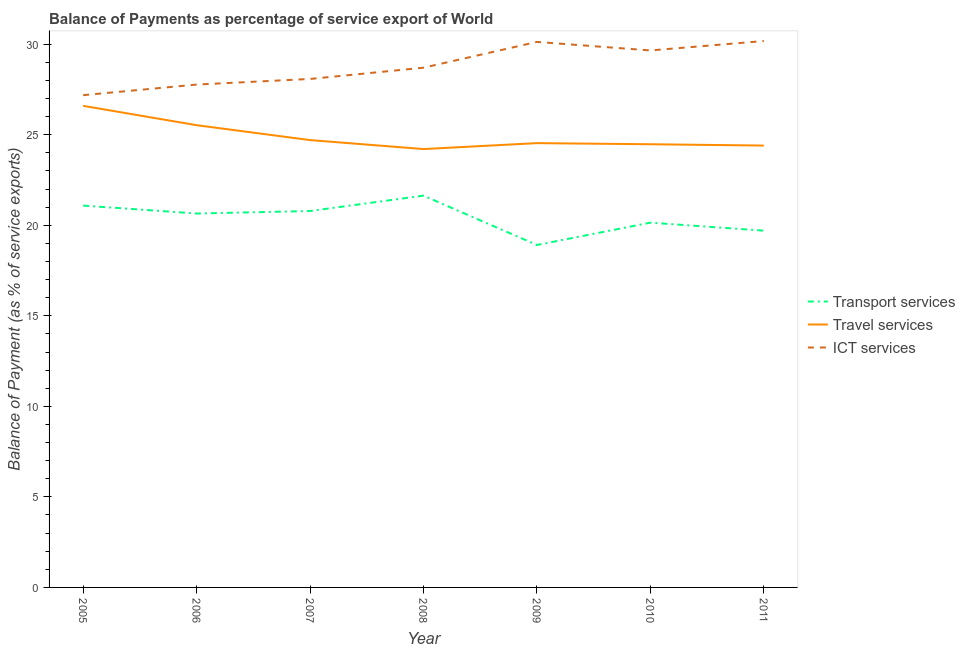How many different coloured lines are there?
Offer a terse response. 3. Does the line corresponding to balance of payment of travel services intersect with the line corresponding to balance of payment of transport services?
Offer a very short reply. No. Is the number of lines equal to the number of legend labels?
Make the answer very short. Yes. What is the balance of payment of ict services in 2008?
Keep it short and to the point. 28.7. Across all years, what is the maximum balance of payment of travel services?
Offer a terse response. 26.59. Across all years, what is the minimum balance of payment of travel services?
Your answer should be very brief. 24.21. In which year was the balance of payment of travel services minimum?
Ensure brevity in your answer.  2008. What is the total balance of payment of ict services in the graph?
Offer a terse response. 201.69. What is the difference between the balance of payment of travel services in 2008 and that in 2011?
Keep it short and to the point. -0.19. What is the difference between the balance of payment of transport services in 2008 and the balance of payment of travel services in 2007?
Offer a terse response. -3.07. What is the average balance of payment of travel services per year?
Provide a short and direct response. 24.92. In the year 2008, what is the difference between the balance of payment of transport services and balance of payment of travel services?
Make the answer very short. -2.57. In how many years, is the balance of payment of travel services greater than 18 %?
Your response must be concise. 7. What is the ratio of the balance of payment of ict services in 2010 to that in 2011?
Make the answer very short. 0.98. Is the balance of payment of travel services in 2005 less than that in 2006?
Provide a short and direct response. No. Is the difference between the balance of payment of transport services in 2005 and 2008 greater than the difference between the balance of payment of ict services in 2005 and 2008?
Ensure brevity in your answer.  Yes. What is the difference between the highest and the second highest balance of payment of ict services?
Your answer should be very brief. 0.05. What is the difference between the highest and the lowest balance of payment of ict services?
Your response must be concise. 2.99. In how many years, is the balance of payment of travel services greater than the average balance of payment of travel services taken over all years?
Keep it short and to the point. 2. Is it the case that in every year, the sum of the balance of payment of transport services and balance of payment of travel services is greater than the balance of payment of ict services?
Your answer should be compact. Yes. Does the balance of payment of transport services monotonically increase over the years?
Provide a succinct answer. No. What is the difference between two consecutive major ticks on the Y-axis?
Ensure brevity in your answer.  5. Does the graph contain any zero values?
Offer a terse response. No. Does the graph contain grids?
Ensure brevity in your answer.  No. Where does the legend appear in the graph?
Make the answer very short. Center right. What is the title of the graph?
Your answer should be very brief. Balance of Payments as percentage of service export of World. What is the label or title of the Y-axis?
Make the answer very short. Balance of Payment (as % of service exports). What is the Balance of Payment (as % of service exports) of Transport services in 2005?
Give a very brief answer. 21.09. What is the Balance of Payment (as % of service exports) of Travel services in 2005?
Your answer should be very brief. 26.59. What is the Balance of Payment (as % of service exports) in ICT services in 2005?
Offer a very short reply. 27.19. What is the Balance of Payment (as % of service exports) of Transport services in 2006?
Your answer should be very brief. 20.65. What is the Balance of Payment (as % of service exports) in Travel services in 2006?
Your response must be concise. 25.53. What is the Balance of Payment (as % of service exports) in ICT services in 2006?
Offer a terse response. 27.77. What is the Balance of Payment (as % of service exports) in Transport services in 2007?
Ensure brevity in your answer.  20.79. What is the Balance of Payment (as % of service exports) in Travel services in 2007?
Give a very brief answer. 24.7. What is the Balance of Payment (as % of service exports) in ICT services in 2007?
Your answer should be very brief. 28.08. What is the Balance of Payment (as % of service exports) in Transport services in 2008?
Provide a short and direct response. 21.64. What is the Balance of Payment (as % of service exports) in Travel services in 2008?
Your answer should be very brief. 24.21. What is the Balance of Payment (as % of service exports) in ICT services in 2008?
Give a very brief answer. 28.7. What is the Balance of Payment (as % of service exports) in Transport services in 2009?
Offer a terse response. 18.91. What is the Balance of Payment (as % of service exports) of Travel services in 2009?
Keep it short and to the point. 24.54. What is the Balance of Payment (as % of service exports) of ICT services in 2009?
Your answer should be compact. 30.13. What is the Balance of Payment (as % of service exports) of Transport services in 2010?
Your response must be concise. 20.14. What is the Balance of Payment (as % of service exports) of Travel services in 2010?
Offer a very short reply. 24.47. What is the Balance of Payment (as % of service exports) of ICT services in 2010?
Keep it short and to the point. 29.65. What is the Balance of Payment (as % of service exports) of Transport services in 2011?
Give a very brief answer. 19.7. What is the Balance of Payment (as % of service exports) in Travel services in 2011?
Keep it short and to the point. 24.4. What is the Balance of Payment (as % of service exports) in ICT services in 2011?
Keep it short and to the point. 30.17. Across all years, what is the maximum Balance of Payment (as % of service exports) of Transport services?
Your answer should be very brief. 21.64. Across all years, what is the maximum Balance of Payment (as % of service exports) of Travel services?
Give a very brief answer. 26.59. Across all years, what is the maximum Balance of Payment (as % of service exports) in ICT services?
Give a very brief answer. 30.17. Across all years, what is the minimum Balance of Payment (as % of service exports) of Transport services?
Your answer should be compact. 18.91. Across all years, what is the minimum Balance of Payment (as % of service exports) of Travel services?
Give a very brief answer. 24.21. Across all years, what is the minimum Balance of Payment (as % of service exports) in ICT services?
Your answer should be very brief. 27.19. What is the total Balance of Payment (as % of service exports) in Transport services in the graph?
Provide a short and direct response. 142.92. What is the total Balance of Payment (as % of service exports) in Travel services in the graph?
Offer a very short reply. 174.45. What is the total Balance of Payment (as % of service exports) of ICT services in the graph?
Offer a very short reply. 201.69. What is the difference between the Balance of Payment (as % of service exports) in Transport services in 2005 and that in 2006?
Offer a terse response. 0.44. What is the difference between the Balance of Payment (as % of service exports) in Travel services in 2005 and that in 2006?
Keep it short and to the point. 1.07. What is the difference between the Balance of Payment (as % of service exports) of ICT services in 2005 and that in 2006?
Your answer should be compact. -0.59. What is the difference between the Balance of Payment (as % of service exports) of Transport services in 2005 and that in 2007?
Give a very brief answer. 0.3. What is the difference between the Balance of Payment (as % of service exports) in Travel services in 2005 and that in 2007?
Your response must be concise. 1.89. What is the difference between the Balance of Payment (as % of service exports) of ICT services in 2005 and that in 2007?
Give a very brief answer. -0.9. What is the difference between the Balance of Payment (as % of service exports) in Transport services in 2005 and that in 2008?
Your response must be concise. -0.55. What is the difference between the Balance of Payment (as % of service exports) of Travel services in 2005 and that in 2008?
Ensure brevity in your answer.  2.39. What is the difference between the Balance of Payment (as % of service exports) in ICT services in 2005 and that in 2008?
Ensure brevity in your answer.  -1.52. What is the difference between the Balance of Payment (as % of service exports) of Transport services in 2005 and that in 2009?
Provide a succinct answer. 2.18. What is the difference between the Balance of Payment (as % of service exports) in Travel services in 2005 and that in 2009?
Keep it short and to the point. 2.06. What is the difference between the Balance of Payment (as % of service exports) of ICT services in 2005 and that in 2009?
Your response must be concise. -2.94. What is the difference between the Balance of Payment (as % of service exports) in Transport services in 2005 and that in 2010?
Offer a very short reply. 0.94. What is the difference between the Balance of Payment (as % of service exports) of Travel services in 2005 and that in 2010?
Give a very brief answer. 2.12. What is the difference between the Balance of Payment (as % of service exports) in ICT services in 2005 and that in 2010?
Your answer should be very brief. -2.47. What is the difference between the Balance of Payment (as % of service exports) of Transport services in 2005 and that in 2011?
Your answer should be compact. 1.39. What is the difference between the Balance of Payment (as % of service exports) of Travel services in 2005 and that in 2011?
Provide a short and direct response. 2.19. What is the difference between the Balance of Payment (as % of service exports) in ICT services in 2005 and that in 2011?
Make the answer very short. -2.99. What is the difference between the Balance of Payment (as % of service exports) of Transport services in 2006 and that in 2007?
Ensure brevity in your answer.  -0.14. What is the difference between the Balance of Payment (as % of service exports) of Travel services in 2006 and that in 2007?
Make the answer very short. 0.82. What is the difference between the Balance of Payment (as % of service exports) in ICT services in 2006 and that in 2007?
Make the answer very short. -0.31. What is the difference between the Balance of Payment (as % of service exports) in Transport services in 2006 and that in 2008?
Your answer should be very brief. -0.99. What is the difference between the Balance of Payment (as % of service exports) in Travel services in 2006 and that in 2008?
Provide a succinct answer. 1.32. What is the difference between the Balance of Payment (as % of service exports) in ICT services in 2006 and that in 2008?
Keep it short and to the point. -0.93. What is the difference between the Balance of Payment (as % of service exports) of Transport services in 2006 and that in 2009?
Make the answer very short. 1.74. What is the difference between the Balance of Payment (as % of service exports) in Travel services in 2006 and that in 2009?
Make the answer very short. 0.99. What is the difference between the Balance of Payment (as % of service exports) in ICT services in 2006 and that in 2009?
Your answer should be very brief. -2.36. What is the difference between the Balance of Payment (as % of service exports) in Transport services in 2006 and that in 2010?
Offer a very short reply. 0.5. What is the difference between the Balance of Payment (as % of service exports) of Travel services in 2006 and that in 2010?
Offer a terse response. 1.05. What is the difference between the Balance of Payment (as % of service exports) of ICT services in 2006 and that in 2010?
Provide a succinct answer. -1.88. What is the difference between the Balance of Payment (as % of service exports) of Transport services in 2006 and that in 2011?
Give a very brief answer. 0.95. What is the difference between the Balance of Payment (as % of service exports) of Travel services in 2006 and that in 2011?
Make the answer very short. 1.12. What is the difference between the Balance of Payment (as % of service exports) of ICT services in 2006 and that in 2011?
Offer a terse response. -2.4. What is the difference between the Balance of Payment (as % of service exports) in Transport services in 2007 and that in 2008?
Ensure brevity in your answer.  -0.85. What is the difference between the Balance of Payment (as % of service exports) in Travel services in 2007 and that in 2008?
Ensure brevity in your answer.  0.5. What is the difference between the Balance of Payment (as % of service exports) in ICT services in 2007 and that in 2008?
Offer a very short reply. -0.62. What is the difference between the Balance of Payment (as % of service exports) of Transport services in 2007 and that in 2009?
Offer a very short reply. 1.88. What is the difference between the Balance of Payment (as % of service exports) of Travel services in 2007 and that in 2009?
Offer a terse response. 0.17. What is the difference between the Balance of Payment (as % of service exports) in ICT services in 2007 and that in 2009?
Give a very brief answer. -2.05. What is the difference between the Balance of Payment (as % of service exports) in Transport services in 2007 and that in 2010?
Your response must be concise. 0.64. What is the difference between the Balance of Payment (as % of service exports) in Travel services in 2007 and that in 2010?
Give a very brief answer. 0.23. What is the difference between the Balance of Payment (as % of service exports) of ICT services in 2007 and that in 2010?
Make the answer very short. -1.57. What is the difference between the Balance of Payment (as % of service exports) of Transport services in 2007 and that in 2011?
Ensure brevity in your answer.  1.08. What is the difference between the Balance of Payment (as % of service exports) in Travel services in 2007 and that in 2011?
Offer a terse response. 0.3. What is the difference between the Balance of Payment (as % of service exports) of ICT services in 2007 and that in 2011?
Make the answer very short. -2.09. What is the difference between the Balance of Payment (as % of service exports) in Transport services in 2008 and that in 2009?
Offer a very short reply. 2.73. What is the difference between the Balance of Payment (as % of service exports) of Travel services in 2008 and that in 2009?
Make the answer very short. -0.33. What is the difference between the Balance of Payment (as % of service exports) of ICT services in 2008 and that in 2009?
Provide a succinct answer. -1.42. What is the difference between the Balance of Payment (as % of service exports) of Transport services in 2008 and that in 2010?
Ensure brevity in your answer.  1.49. What is the difference between the Balance of Payment (as % of service exports) in Travel services in 2008 and that in 2010?
Your answer should be compact. -0.27. What is the difference between the Balance of Payment (as % of service exports) in ICT services in 2008 and that in 2010?
Offer a very short reply. -0.95. What is the difference between the Balance of Payment (as % of service exports) in Transport services in 2008 and that in 2011?
Keep it short and to the point. 1.93. What is the difference between the Balance of Payment (as % of service exports) of Travel services in 2008 and that in 2011?
Your answer should be very brief. -0.19. What is the difference between the Balance of Payment (as % of service exports) in ICT services in 2008 and that in 2011?
Your answer should be compact. -1.47. What is the difference between the Balance of Payment (as % of service exports) in Transport services in 2009 and that in 2010?
Ensure brevity in your answer.  -1.23. What is the difference between the Balance of Payment (as % of service exports) of Travel services in 2009 and that in 2010?
Offer a very short reply. 0.06. What is the difference between the Balance of Payment (as % of service exports) of ICT services in 2009 and that in 2010?
Make the answer very short. 0.47. What is the difference between the Balance of Payment (as % of service exports) of Transport services in 2009 and that in 2011?
Your response must be concise. -0.79. What is the difference between the Balance of Payment (as % of service exports) in Travel services in 2009 and that in 2011?
Offer a very short reply. 0.13. What is the difference between the Balance of Payment (as % of service exports) in ICT services in 2009 and that in 2011?
Provide a succinct answer. -0.05. What is the difference between the Balance of Payment (as % of service exports) in Transport services in 2010 and that in 2011?
Ensure brevity in your answer.  0.44. What is the difference between the Balance of Payment (as % of service exports) of Travel services in 2010 and that in 2011?
Provide a short and direct response. 0.07. What is the difference between the Balance of Payment (as % of service exports) of ICT services in 2010 and that in 2011?
Make the answer very short. -0.52. What is the difference between the Balance of Payment (as % of service exports) of Transport services in 2005 and the Balance of Payment (as % of service exports) of Travel services in 2006?
Provide a short and direct response. -4.44. What is the difference between the Balance of Payment (as % of service exports) of Transport services in 2005 and the Balance of Payment (as % of service exports) of ICT services in 2006?
Keep it short and to the point. -6.68. What is the difference between the Balance of Payment (as % of service exports) in Travel services in 2005 and the Balance of Payment (as % of service exports) in ICT services in 2006?
Your answer should be very brief. -1.18. What is the difference between the Balance of Payment (as % of service exports) in Transport services in 2005 and the Balance of Payment (as % of service exports) in Travel services in 2007?
Make the answer very short. -3.62. What is the difference between the Balance of Payment (as % of service exports) in Transport services in 2005 and the Balance of Payment (as % of service exports) in ICT services in 2007?
Your answer should be compact. -6.99. What is the difference between the Balance of Payment (as % of service exports) in Travel services in 2005 and the Balance of Payment (as % of service exports) in ICT services in 2007?
Your answer should be compact. -1.49. What is the difference between the Balance of Payment (as % of service exports) in Transport services in 2005 and the Balance of Payment (as % of service exports) in Travel services in 2008?
Your response must be concise. -3.12. What is the difference between the Balance of Payment (as % of service exports) in Transport services in 2005 and the Balance of Payment (as % of service exports) in ICT services in 2008?
Provide a short and direct response. -7.61. What is the difference between the Balance of Payment (as % of service exports) of Travel services in 2005 and the Balance of Payment (as % of service exports) of ICT services in 2008?
Provide a succinct answer. -2.11. What is the difference between the Balance of Payment (as % of service exports) of Transport services in 2005 and the Balance of Payment (as % of service exports) of Travel services in 2009?
Make the answer very short. -3.45. What is the difference between the Balance of Payment (as % of service exports) in Transport services in 2005 and the Balance of Payment (as % of service exports) in ICT services in 2009?
Offer a very short reply. -9.04. What is the difference between the Balance of Payment (as % of service exports) of Travel services in 2005 and the Balance of Payment (as % of service exports) of ICT services in 2009?
Your answer should be very brief. -3.53. What is the difference between the Balance of Payment (as % of service exports) in Transport services in 2005 and the Balance of Payment (as % of service exports) in Travel services in 2010?
Keep it short and to the point. -3.39. What is the difference between the Balance of Payment (as % of service exports) in Transport services in 2005 and the Balance of Payment (as % of service exports) in ICT services in 2010?
Your answer should be compact. -8.57. What is the difference between the Balance of Payment (as % of service exports) of Travel services in 2005 and the Balance of Payment (as % of service exports) of ICT services in 2010?
Provide a succinct answer. -3.06. What is the difference between the Balance of Payment (as % of service exports) of Transport services in 2005 and the Balance of Payment (as % of service exports) of Travel services in 2011?
Give a very brief answer. -3.31. What is the difference between the Balance of Payment (as % of service exports) in Transport services in 2005 and the Balance of Payment (as % of service exports) in ICT services in 2011?
Give a very brief answer. -9.09. What is the difference between the Balance of Payment (as % of service exports) of Travel services in 2005 and the Balance of Payment (as % of service exports) of ICT services in 2011?
Offer a very short reply. -3.58. What is the difference between the Balance of Payment (as % of service exports) of Transport services in 2006 and the Balance of Payment (as % of service exports) of Travel services in 2007?
Provide a short and direct response. -4.06. What is the difference between the Balance of Payment (as % of service exports) of Transport services in 2006 and the Balance of Payment (as % of service exports) of ICT services in 2007?
Your answer should be compact. -7.43. What is the difference between the Balance of Payment (as % of service exports) in Travel services in 2006 and the Balance of Payment (as % of service exports) in ICT services in 2007?
Give a very brief answer. -2.55. What is the difference between the Balance of Payment (as % of service exports) of Transport services in 2006 and the Balance of Payment (as % of service exports) of Travel services in 2008?
Your response must be concise. -3.56. What is the difference between the Balance of Payment (as % of service exports) of Transport services in 2006 and the Balance of Payment (as % of service exports) of ICT services in 2008?
Your response must be concise. -8.05. What is the difference between the Balance of Payment (as % of service exports) of Travel services in 2006 and the Balance of Payment (as % of service exports) of ICT services in 2008?
Provide a short and direct response. -3.18. What is the difference between the Balance of Payment (as % of service exports) in Transport services in 2006 and the Balance of Payment (as % of service exports) in Travel services in 2009?
Ensure brevity in your answer.  -3.89. What is the difference between the Balance of Payment (as % of service exports) in Transport services in 2006 and the Balance of Payment (as % of service exports) in ICT services in 2009?
Provide a short and direct response. -9.48. What is the difference between the Balance of Payment (as % of service exports) in Travel services in 2006 and the Balance of Payment (as % of service exports) in ICT services in 2009?
Your response must be concise. -4.6. What is the difference between the Balance of Payment (as % of service exports) of Transport services in 2006 and the Balance of Payment (as % of service exports) of Travel services in 2010?
Ensure brevity in your answer.  -3.83. What is the difference between the Balance of Payment (as % of service exports) of Transport services in 2006 and the Balance of Payment (as % of service exports) of ICT services in 2010?
Your answer should be compact. -9.01. What is the difference between the Balance of Payment (as % of service exports) of Travel services in 2006 and the Balance of Payment (as % of service exports) of ICT services in 2010?
Your answer should be very brief. -4.13. What is the difference between the Balance of Payment (as % of service exports) in Transport services in 2006 and the Balance of Payment (as % of service exports) in Travel services in 2011?
Keep it short and to the point. -3.75. What is the difference between the Balance of Payment (as % of service exports) in Transport services in 2006 and the Balance of Payment (as % of service exports) in ICT services in 2011?
Provide a succinct answer. -9.53. What is the difference between the Balance of Payment (as % of service exports) in Travel services in 2006 and the Balance of Payment (as % of service exports) in ICT services in 2011?
Ensure brevity in your answer.  -4.65. What is the difference between the Balance of Payment (as % of service exports) in Transport services in 2007 and the Balance of Payment (as % of service exports) in Travel services in 2008?
Your response must be concise. -3.42. What is the difference between the Balance of Payment (as % of service exports) in Transport services in 2007 and the Balance of Payment (as % of service exports) in ICT services in 2008?
Make the answer very short. -7.92. What is the difference between the Balance of Payment (as % of service exports) of Travel services in 2007 and the Balance of Payment (as % of service exports) of ICT services in 2008?
Offer a terse response. -4. What is the difference between the Balance of Payment (as % of service exports) of Transport services in 2007 and the Balance of Payment (as % of service exports) of Travel services in 2009?
Offer a terse response. -3.75. What is the difference between the Balance of Payment (as % of service exports) in Transport services in 2007 and the Balance of Payment (as % of service exports) in ICT services in 2009?
Offer a very short reply. -9.34. What is the difference between the Balance of Payment (as % of service exports) of Travel services in 2007 and the Balance of Payment (as % of service exports) of ICT services in 2009?
Your answer should be very brief. -5.42. What is the difference between the Balance of Payment (as % of service exports) of Transport services in 2007 and the Balance of Payment (as % of service exports) of Travel services in 2010?
Offer a very short reply. -3.69. What is the difference between the Balance of Payment (as % of service exports) in Transport services in 2007 and the Balance of Payment (as % of service exports) in ICT services in 2010?
Provide a succinct answer. -8.87. What is the difference between the Balance of Payment (as % of service exports) in Travel services in 2007 and the Balance of Payment (as % of service exports) in ICT services in 2010?
Ensure brevity in your answer.  -4.95. What is the difference between the Balance of Payment (as % of service exports) of Transport services in 2007 and the Balance of Payment (as % of service exports) of Travel services in 2011?
Offer a terse response. -3.62. What is the difference between the Balance of Payment (as % of service exports) of Transport services in 2007 and the Balance of Payment (as % of service exports) of ICT services in 2011?
Your answer should be compact. -9.39. What is the difference between the Balance of Payment (as % of service exports) of Travel services in 2007 and the Balance of Payment (as % of service exports) of ICT services in 2011?
Your response must be concise. -5.47. What is the difference between the Balance of Payment (as % of service exports) of Transport services in 2008 and the Balance of Payment (as % of service exports) of Travel services in 2009?
Give a very brief answer. -2.9. What is the difference between the Balance of Payment (as % of service exports) of Transport services in 2008 and the Balance of Payment (as % of service exports) of ICT services in 2009?
Keep it short and to the point. -8.49. What is the difference between the Balance of Payment (as % of service exports) in Travel services in 2008 and the Balance of Payment (as % of service exports) in ICT services in 2009?
Your answer should be very brief. -5.92. What is the difference between the Balance of Payment (as % of service exports) in Transport services in 2008 and the Balance of Payment (as % of service exports) in Travel services in 2010?
Ensure brevity in your answer.  -2.84. What is the difference between the Balance of Payment (as % of service exports) of Transport services in 2008 and the Balance of Payment (as % of service exports) of ICT services in 2010?
Your answer should be very brief. -8.02. What is the difference between the Balance of Payment (as % of service exports) of Travel services in 2008 and the Balance of Payment (as % of service exports) of ICT services in 2010?
Offer a terse response. -5.45. What is the difference between the Balance of Payment (as % of service exports) in Transport services in 2008 and the Balance of Payment (as % of service exports) in Travel services in 2011?
Your response must be concise. -2.77. What is the difference between the Balance of Payment (as % of service exports) of Transport services in 2008 and the Balance of Payment (as % of service exports) of ICT services in 2011?
Your answer should be very brief. -8.54. What is the difference between the Balance of Payment (as % of service exports) of Travel services in 2008 and the Balance of Payment (as % of service exports) of ICT services in 2011?
Make the answer very short. -5.97. What is the difference between the Balance of Payment (as % of service exports) in Transport services in 2009 and the Balance of Payment (as % of service exports) in Travel services in 2010?
Your answer should be very brief. -5.56. What is the difference between the Balance of Payment (as % of service exports) in Transport services in 2009 and the Balance of Payment (as % of service exports) in ICT services in 2010?
Your response must be concise. -10.74. What is the difference between the Balance of Payment (as % of service exports) in Travel services in 2009 and the Balance of Payment (as % of service exports) in ICT services in 2010?
Ensure brevity in your answer.  -5.12. What is the difference between the Balance of Payment (as % of service exports) in Transport services in 2009 and the Balance of Payment (as % of service exports) in Travel services in 2011?
Give a very brief answer. -5.49. What is the difference between the Balance of Payment (as % of service exports) in Transport services in 2009 and the Balance of Payment (as % of service exports) in ICT services in 2011?
Keep it short and to the point. -11.26. What is the difference between the Balance of Payment (as % of service exports) in Travel services in 2009 and the Balance of Payment (as % of service exports) in ICT services in 2011?
Give a very brief answer. -5.64. What is the difference between the Balance of Payment (as % of service exports) in Transport services in 2010 and the Balance of Payment (as % of service exports) in Travel services in 2011?
Provide a succinct answer. -4.26. What is the difference between the Balance of Payment (as % of service exports) of Transport services in 2010 and the Balance of Payment (as % of service exports) of ICT services in 2011?
Your answer should be compact. -10.03. What is the difference between the Balance of Payment (as % of service exports) of Travel services in 2010 and the Balance of Payment (as % of service exports) of ICT services in 2011?
Your answer should be very brief. -5.7. What is the average Balance of Payment (as % of service exports) in Transport services per year?
Offer a very short reply. 20.42. What is the average Balance of Payment (as % of service exports) in Travel services per year?
Your answer should be very brief. 24.92. What is the average Balance of Payment (as % of service exports) of ICT services per year?
Offer a terse response. 28.81. In the year 2005, what is the difference between the Balance of Payment (as % of service exports) of Transport services and Balance of Payment (as % of service exports) of Travel services?
Ensure brevity in your answer.  -5.51. In the year 2005, what is the difference between the Balance of Payment (as % of service exports) of Transport services and Balance of Payment (as % of service exports) of ICT services?
Offer a terse response. -6.1. In the year 2005, what is the difference between the Balance of Payment (as % of service exports) of Travel services and Balance of Payment (as % of service exports) of ICT services?
Offer a very short reply. -0.59. In the year 2006, what is the difference between the Balance of Payment (as % of service exports) of Transport services and Balance of Payment (as % of service exports) of Travel services?
Offer a terse response. -4.88. In the year 2006, what is the difference between the Balance of Payment (as % of service exports) in Transport services and Balance of Payment (as % of service exports) in ICT services?
Your answer should be compact. -7.12. In the year 2006, what is the difference between the Balance of Payment (as % of service exports) of Travel services and Balance of Payment (as % of service exports) of ICT services?
Your answer should be very brief. -2.24. In the year 2007, what is the difference between the Balance of Payment (as % of service exports) of Transport services and Balance of Payment (as % of service exports) of Travel services?
Provide a short and direct response. -3.92. In the year 2007, what is the difference between the Balance of Payment (as % of service exports) of Transport services and Balance of Payment (as % of service exports) of ICT services?
Keep it short and to the point. -7.29. In the year 2007, what is the difference between the Balance of Payment (as % of service exports) of Travel services and Balance of Payment (as % of service exports) of ICT services?
Your response must be concise. -3.38. In the year 2008, what is the difference between the Balance of Payment (as % of service exports) in Transport services and Balance of Payment (as % of service exports) in Travel services?
Make the answer very short. -2.57. In the year 2008, what is the difference between the Balance of Payment (as % of service exports) of Transport services and Balance of Payment (as % of service exports) of ICT services?
Your answer should be very brief. -7.07. In the year 2008, what is the difference between the Balance of Payment (as % of service exports) in Travel services and Balance of Payment (as % of service exports) in ICT services?
Offer a very short reply. -4.49. In the year 2009, what is the difference between the Balance of Payment (as % of service exports) of Transport services and Balance of Payment (as % of service exports) of Travel services?
Make the answer very short. -5.63. In the year 2009, what is the difference between the Balance of Payment (as % of service exports) of Transport services and Balance of Payment (as % of service exports) of ICT services?
Offer a very short reply. -11.21. In the year 2009, what is the difference between the Balance of Payment (as % of service exports) in Travel services and Balance of Payment (as % of service exports) in ICT services?
Provide a short and direct response. -5.59. In the year 2010, what is the difference between the Balance of Payment (as % of service exports) of Transport services and Balance of Payment (as % of service exports) of Travel services?
Provide a short and direct response. -4.33. In the year 2010, what is the difference between the Balance of Payment (as % of service exports) in Transport services and Balance of Payment (as % of service exports) in ICT services?
Provide a succinct answer. -9.51. In the year 2010, what is the difference between the Balance of Payment (as % of service exports) of Travel services and Balance of Payment (as % of service exports) of ICT services?
Keep it short and to the point. -5.18. In the year 2011, what is the difference between the Balance of Payment (as % of service exports) of Transport services and Balance of Payment (as % of service exports) of Travel services?
Offer a terse response. -4.7. In the year 2011, what is the difference between the Balance of Payment (as % of service exports) of Transport services and Balance of Payment (as % of service exports) of ICT services?
Make the answer very short. -10.47. In the year 2011, what is the difference between the Balance of Payment (as % of service exports) in Travel services and Balance of Payment (as % of service exports) in ICT services?
Your response must be concise. -5.77. What is the ratio of the Balance of Payment (as % of service exports) in Transport services in 2005 to that in 2006?
Your answer should be compact. 1.02. What is the ratio of the Balance of Payment (as % of service exports) of Travel services in 2005 to that in 2006?
Give a very brief answer. 1.04. What is the ratio of the Balance of Payment (as % of service exports) in ICT services in 2005 to that in 2006?
Provide a succinct answer. 0.98. What is the ratio of the Balance of Payment (as % of service exports) in Transport services in 2005 to that in 2007?
Provide a short and direct response. 1.01. What is the ratio of the Balance of Payment (as % of service exports) of Travel services in 2005 to that in 2007?
Keep it short and to the point. 1.08. What is the ratio of the Balance of Payment (as % of service exports) of ICT services in 2005 to that in 2007?
Your answer should be compact. 0.97. What is the ratio of the Balance of Payment (as % of service exports) in Transport services in 2005 to that in 2008?
Your answer should be compact. 0.97. What is the ratio of the Balance of Payment (as % of service exports) in Travel services in 2005 to that in 2008?
Offer a terse response. 1.1. What is the ratio of the Balance of Payment (as % of service exports) in ICT services in 2005 to that in 2008?
Provide a short and direct response. 0.95. What is the ratio of the Balance of Payment (as % of service exports) of Transport services in 2005 to that in 2009?
Keep it short and to the point. 1.12. What is the ratio of the Balance of Payment (as % of service exports) in Travel services in 2005 to that in 2009?
Your answer should be compact. 1.08. What is the ratio of the Balance of Payment (as % of service exports) in ICT services in 2005 to that in 2009?
Provide a succinct answer. 0.9. What is the ratio of the Balance of Payment (as % of service exports) in Transport services in 2005 to that in 2010?
Ensure brevity in your answer.  1.05. What is the ratio of the Balance of Payment (as % of service exports) in Travel services in 2005 to that in 2010?
Your answer should be compact. 1.09. What is the ratio of the Balance of Payment (as % of service exports) in ICT services in 2005 to that in 2010?
Provide a succinct answer. 0.92. What is the ratio of the Balance of Payment (as % of service exports) of Transport services in 2005 to that in 2011?
Give a very brief answer. 1.07. What is the ratio of the Balance of Payment (as % of service exports) in Travel services in 2005 to that in 2011?
Provide a succinct answer. 1.09. What is the ratio of the Balance of Payment (as % of service exports) of ICT services in 2005 to that in 2011?
Offer a very short reply. 0.9. What is the ratio of the Balance of Payment (as % of service exports) in Travel services in 2006 to that in 2007?
Provide a short and direct response. 1.03. What is the ratio of the Balance of Payment (as % of service exports) of ICT services in 2006 to that in 2007?
Provide a succinct answer. 0.99. What is the ratio of the Balance of Payment (as % of service exports) of Transport services in 2006 to that in 2008?
Make the answer very short. 0.95. What is the ratio of the Balance of Payment (as % of service exports) of Travel services in 2006 to that in 2008?
Make the answer very short. 1.05. What is the ratio of the Balance of Payment (as % of service exports) of ICT services in 2006 to that in 2008?
Provide a succinct answer. 0.97. What is the ratio of the Balance of Payment (as % of service exports) of Transport services in 2006 to that in 2009?
Make the answer very short. 1.09. What is the ratio of the Balance of Payment (as % of service exports) of Travel services in 2006 to that in 2009?
Offer a terse response. 1.04. What is the ratio of the Balance of Payment (as % of service exports) of ICT services in 2006 to that in 2009?
Your response must be concise. 0.92. What is the ratio of the Balance of Payment (as % of service exports) of Travel services in 2006 to that in 2010?
Provide a succinct answer. 1.04. What is the ratio of the Balance of Payment (as % of service exports) in ICT services in 2006 to that in 2010?
Ensure brevity in your answer.  0.94. What is the ratio of the Balance of Payment (as % of service exports) of Transport services in 2006 to that in 2011?
Ensure brevity in your answer.  1.05. What is the ratio of the Balance of Payment (as % of service exports) of Travel services in 2006 to that in 2011?
Provide a short and direct response. 1.05. What is the ratio of the Balance of Payment (as % of service exports) in ICT services in 2006 to that in 2011?
Your answer should be very brief. 0.92. What is the ratio of the Balance of Payment (as % of service exports) of Transport services in 2007 to that in 2008?
Your answer should be very brief. 0.96. What is the ratio of the Balance of Payment (as % of service exports) of Travel services in 2007 to that in 2008?
Offer a terse response. 1.02. What is the ratio of the Balance of Payment (as % of service exports) of ICT services in 2007 to that in 2008?
Your response must be concise. 0.98. What is the ratio of the Balance of Payment (as % of service exports) in Transport services in 2007 to that in 2009?
Your response must be concise. 1.1. What is the ratio of the Balance of Payment (as % of service exports) in Travel services in 2007 to that in 2009?
Your answer should be very brief. 1.01. What is the ratio of the Balance of Payment (as % of service exports) of ICT services in 2007 to that in 2009?
Your answer should be very brief. 0.93. What is the ratio of the Balance of Payment (as % of service exports) in Transport services in 2007 to that in 2010?
Give a very brief answer. 1.03. What is the ratio of the Balance of Payment (as % of service exports) in Travel services in 2007 to that in 2010?
Keep it short and to the point. 1.01. What is the ratio of the Balance of Payment (as % of service exports) of ICT services in 2007 to that in 2010?
Provide a succinct answer. 0.95. What is the ratio of the Balance of Payment (as % of service exports) of Transport services in 2007 to that in 2011?
Give a very brief answer. 1.06. What is the ratio of the Balance of Payment (as % of service exports) of Travel services in 2007 to that in 2011?
Make the answer very short. 1.01. What is the ratio of the Balance of Payment (as % of service exports) in ICT services in 2007 to that in 2011?
Your answer should be very brief. 0.93. What is the ratio of the Balance of Payment (as % of service exports) of Transport services in 2008 to that in 2009?
Provide a short and direct response. 1.14. What is the ratio of the Balance of Payment (as % of service exports) of Travel services in 2008 to that in 2009?
Offer a terse response. 0.99. What is the ratio of the Balance of Payment (as % of service exports) in ICT services in 2008 to that in 2009?
Make the answer very short. 0.95. What is the ratio of the Balance of Payment (as % of service exports) in Transport services in 2008 to that in 2010?
Offer a terse response. 1.07. What is the ratio of the Balance of Payment (as % of service exports) in ICT services in 2008 to that in 2010?
Your answer should be very brief. 0.97. What is the ratio of the Balance of Payment (as % of service exports) in Transport services in 2008 to that in 2011?
Provide a short and direct response. 1.1. What is the ratio of the Balance of Payment (as % of service exports) in Travel services in 2008 to that in 2011?
Make the answer very short. 0.99. What is the ratio of the Balance of Payment (as % of service exports) of ICT services in 2008 to that in 2011?
Offer a very short reply. 0.95. What is the ratio of the Balance of Payment (as % of service exports) of Transport services in 2009 to that in 2010?
Provide a short and direct response. 0.94. What is the ratio of the Balance of Payment (as % of service exports) in Travel services in 2009 to that in 2010?
Offer a terse response. 1. What is the ratio of the Balance of Payment (as % of service exports) in ICT services in 2009 to that in 2010?
Give a very brief answer. 1.02. What is the ratio of the Balance of Payment (as % of service exports) in Transport services in 2009 to that in 2011?
Provide a short and direct response. 0.96. What is the ratio of the Balance of Payment (as % of service exports) in ICT services in 2009 to that in 2011?
Offer a very short reply. 1. What is the ratio of the Balance of Payment (as % of service exports) in Transport services in 2010 to that in 2011?
Offer a very short reply. 1.02. What is the ratio of the Balance of Payment (as % of service exports) of Travel services in 2010 to that in 2011?
Make the answer very short. 1. What is the ratio of the Balance of Payment (as % of service exports) of ICT services in 2010 to that in 2011?
Provide a succinct answer. 0.98. What is the difference between the highest and the second highest Balance of Payment (as % of service exports) in Transport services?
Give a very brief answer. 0.55. What is the difference between the highest and the second highest Balance of Payment (as % of service exports) of Travel services?
Your answer should be very brief. 1.07. What is the difference between the highest and the second highest Balance of Payment (as % of service exports) of ICT services?
Make the answer very short. 0.05. What is the difference between the highest and the lowest Balance of Payment (as % of service exports) of Transport services?
Your response must be concise. 2.73. What is the difference between the highest and the lowest Balance of Payment (as % of service exports) of Travel services?
Make the answer very short. 2.39. What is the difference between the highest and the lowest Balance of Payment (as % of service exports) in ICT services?
Your response must be concise. 2.99. 